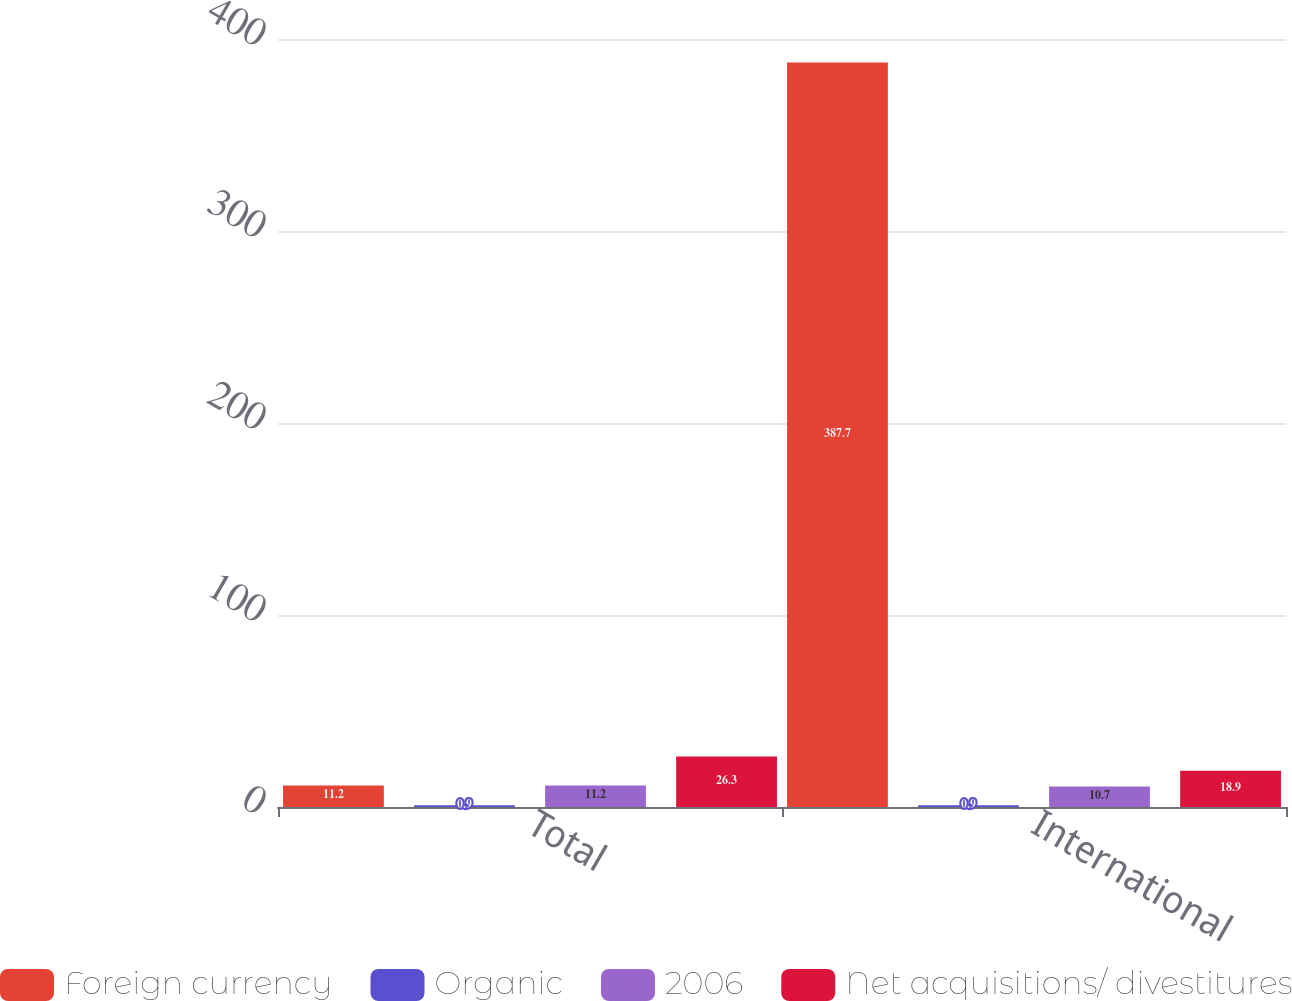<chart> <loc_0><loc_0><loc_500><loc_500><stacked_bar_chart><ecel><fcel>Total<fcel>International<nl><fcel>Foreign currency<fcel>11.2<fcel>387.7<nl><fcel>Organic<fcel>0.9<fcel>0.9<nl><fcel>2006<fcel>11.2<fcel>10.7<nl><fcel>Net acquisitions/ divestitures<fcel>26.3<fcel>18.9<nl></chart> 